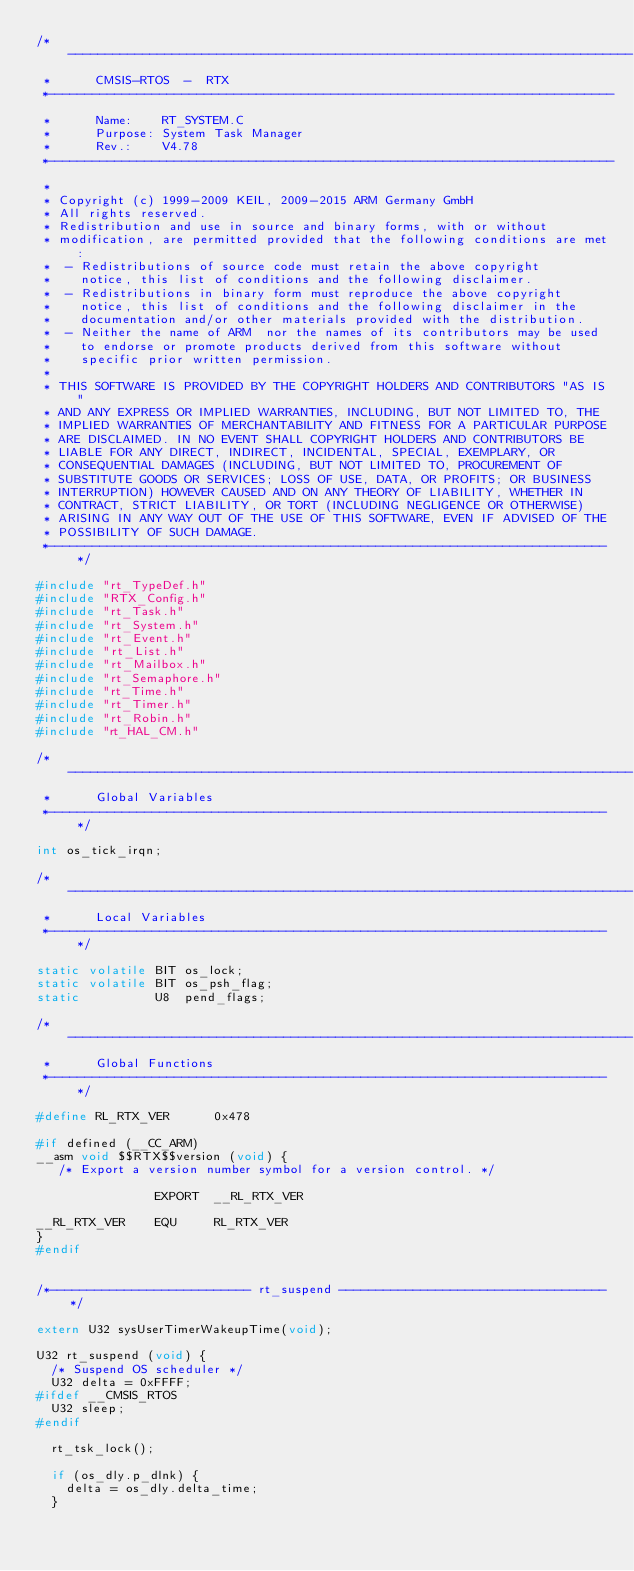<code> <loc_0><loc_0><loc_500><loc_500><_C_>/*----------------------------------------------------------------------------
 *      CMSIS-RTOS  -  RTX
 *----------------------------------------------------------------------------
 *      Name:    RT_SYSTEM.C
 *      Purpose: System Task Manager
 *      Rev.:    V4.78
 *----------------------------------------------------------------------------
 *
 * Copyright (c) 1999-2009 KEIL, 2009-2015 ARM Germany GmbH
 * All rights reserved.
 * Redistribution and use in source and binary forms, with or without
 * modification, are permitted provided that the following conditions are met:
 *  - Redistributions of source code must retain the above copyright
 *    notice, this list of conditions and the following disclaimer.
 *  - Redistributions in binary form must reproduce the above copyright
 *    notice, this list of conditions and the following disclaimer in the
 *    documentation and/or other materials provided with the distribution.
 *  - Neither the name of ARM  nor the names of its contributors may be used 
 *    to endorse or promote products derived from this software without 
 *    specific prior written permission.
 *
 * THIS SOFTWARE IS PROVIDED BY THE COPYRIGHT HOLDERS AND CONTRIBUTORS "AS IS" 
 * AND ANY EXPRESS OR IMPLIED WARRANTIES, INCLUDING, BUT NOT LIMITED TO, THE 
 * IMPLIED WARRANTIES OF MERCHANTABILITY AND FITNESS FOR A PARTICULAR PURPOSE
 * ARE DISCLAIMED. IN NO EVENT SHALL COPYRIGHT HOLDERS AND CONTRIBUTORS BE
 * LIABLE FOR ANY DIRECT, INDIRECT, INCIDENTAL, SPECIAL, EXEMPLARY, OR
 * CONSEQUENTIAL DAMAGES (INCLUDING, BUT NOT LIMITED TO, PROCUREMENT OF 
 * SUBSTITUTE GOODS OR SERVICES; LOSS OF USE, DATA, OR PROFITS; OR BUSINESS 
 * INTERRUPTION) HOWEVER CAUSED AND ON ANY THEORY OF LIABILITY, WHETHER IN 
 * CONTRACT, STRICT LIABILITY, OR TORT (INCLUDING NEGLIGENCE OR OTHERWISE) 
 * ARISING IN ANY WAY OUT OF THE USE OF THIS SOFTWARE, EVEN IF ADVISED OF THE
 * POSSIBILITY OF SUCH DAMAGE.
 *---------------------------------------------------------------------------*/

#include "rt_TypeDef.h"
#include "RTX_Config.h"
#include "rt_Task.h"
#include "rt_System.h"
#include "rt_Event.h"
#include "rt_List.h"
#include "rt_Mailbox.h"
#include "rt_Semaphore.h"
#include "rt_Time.h"
#include "rt_Timer.h"
#include "rt_Robin.h"
#include "rt_HAL_CM.h"

/*----------------------------------------------------------------------------
 *      Global Variables
 *---------------------------------------------------------------------------*/

int os_tick_irqn;

/*----------------------------------------------------------------------------
 *      Local Variables
 *---------------------------------------------------------------------------*/

static volatile BIT os_lock;
static volatile BIT os_psh_flag;
static          U8  pend_flags;

/*----------------------------------------------------------------------------
 *      Global Functions
 *---------------------------------------------------------------------------*/

#define RL_RTX_VER      0x478

#if defined (__CC_ARM)
__asm void $$RTX$$version (void) {
   /* Export a version number symbol for a version control. */

                EXPORT  __RL_RTX_VER

__RL_RTX_VER    EQU     RL_RTX_VER
}
#endif


/*--------------------------- rt_suspend ------------------------------------*/

extern U32 sysUserTimerWakeupTime(void);

U32 rt_suspend (void) {
  /* Suspend OS scheduler */
  U32 delta = 0xFFFF;
#ifdef __CMSIS_RTOS
  U32 sleep;
#endif

  rt_tsk_lock();
  
  if (os_dly.p_dlnk) {
    delta = os_dly.delta_time;
  }</code> 